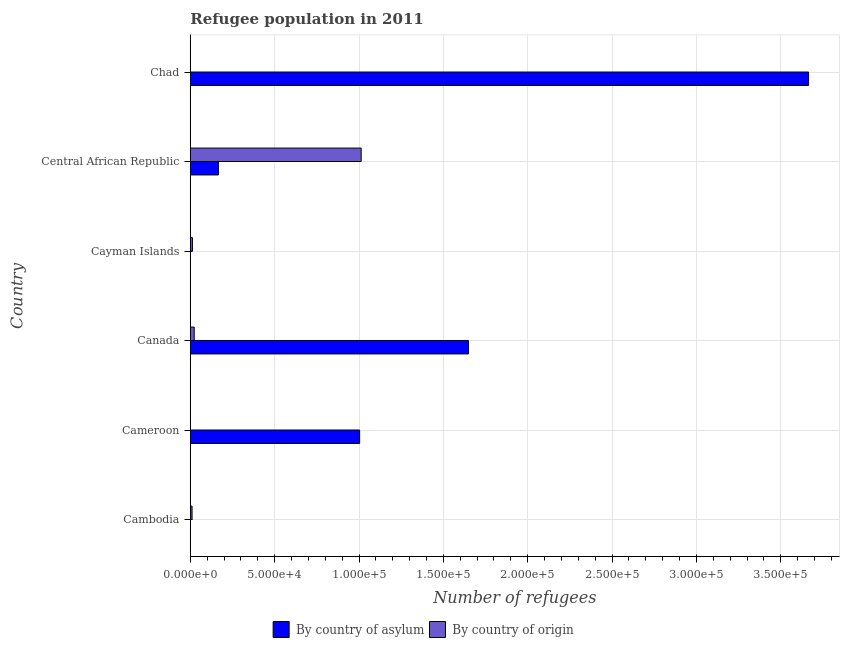How many different coloured bars are there?
Offer a terse response. 2. How many bars are there on the 1st tick from the top?
Keep it short and to the point. 2. What is the label of the 3rd group of bars from the top?
Offer a very short reply. Cayman Islands. What is the number of refugees by country of origin in Central African Republic?
Make the answer very short. 1.01e+05. Across all countries, what is the maximum number of refugees by country of asylum?
Offer a terse response. 3.66e+05. Across all countries, what is the minimum number of refugees by country of origin?
Provide a succinct answer. 1. In which country was the number of refugees by country of asylum maximum?
Ensure brevity in your answer.  Chad. In which country was the number of refugees by country of origin minimum?
Your answer should be very brief. Cameroon. What is the total number of refugees by country of asylum in the graph?
Your answer should be compact. 6.49e+05. What is the difference between the number of refugees by country of asylum in Canada and that in Cayman Islands?
Provide a succinct answer. 1.65e+05. What is the difference between the number of refugees by country of origin in Chad and the number of refugees by country of asylum in Cayman Islands?
Keep it short and to the point. 24. What is the average number of refugees by country of origin per country?
Keep it short and to the point. 1.77e+04. What is the difference between the number of refugees by country of origin and number of refugees by country of asylum in Chad?
Your answer should be compact. -3.66e+05. What is the ratio of the number of refugees by country of origin in Canada to that in Cayman Islands?
Give a very brief answer. 1.83. Is the number of refugees by country of asylum in Cambodia less than that in Cameroon?
Offer a terse response. Yes. Is the difference between the number of refugees by country of origin in Cambodia and Central African Republic greater than the difference between the number of refugees by country of asylum in Cambodia and Central African Republic?
Offer a very short reply. No. What is the difference between the highest and the second highest number of refugees by country of origin?
Give a very brief answer. 9.90e+04. What is the difference between the highest and the lowest number of refugees by country of asylum?
Ensure brevity in your answer.  3.66e+05. What does the 2nd bar from the top in Cambodia represents?
Make the answer very short. By country of asylum. What does the 1st bar from the bottom in Cambodia represents?
Your answer should be compact. By country of asylum. How many countries are there in the graph?
Offer a very short reply. 6. Does the graph contain any zero values?
Your answer should be very brief. No. Does the graph contain grids?
Keep it short and to the point. Yes. Where does the legend appear in the graph?
Keep it short and to the point. Bottom center. How are the legend labels stacked?
Offer a very short reply. Horizontal. What is the title of the graph?
Provide a short and direct response. Refugee population in 2011. What is the label or title of the X-axis?
Your response must be concise. Number of refugees. What is the Number of refugees in By country of asylum in Cambodia?
Your answer should be compact. 64. What is the Number of refugees of By country of origin in Cambodia?
Provide a succinct answer. 1045. What is the Number of refugees of By country of asylum in Cameroon?
Your answer should be very brief. 1.00e+05. What is the Number of refugees in By country of asylum in Canada?
Offer a very short reply. 1.65e+05. What is the Number of refugees of By country of origin in Canada?
Provide a short and direct response. 2327. What is the Number of refugees of By country of origin in Cayman Islands?
Offer a terse response. 1271. What is the Number of refugees in By country of asylum in Central African Republic?
Your response must be concise. 1.67e+04. What is the Number of refugees of By country of origin in Central African Republic?
Make the answer very short. 1.01e+05. What is the Number of refugees in By country of asylum in Chad?
Your answer should be compact. 3.66e+05. Across all countries, what is the maximum Number of refugees in By country of asylum?
Offer a very short reply. 3.66e+05. Across all countries, what is the maximum Number of refugees in By country of origin?
Your answer should be very brief. 1.01e+05. Across all countries, what is the minimum Number of refugees in By country of asylum?
Keep it short and to the point. 3. Across all countries, what is the minimum Number of refugees in By country of origin?
Your response must be concise. 1. What is the total Number of refugees of By country of asylum in the graph?
Your answer should be compact. 6.49e+05. What is the total Number of refugees of By country of origin in the graph?
Make the answer very short. 1.06e+05. What is the difference between the Number of refugees of By country of asylum in Cambodia and that in Cameroon?
Your answer should be very brief. -1.00e+05. What is the difference between the Number of refugees of By country of origin in Cambodia and that in Cameroon?
Provide a succinct answer. 1044. What is the difference between the Number of refugees of By country of asylum in Cambodia and that in Canada?
Your answer should be very brief. -1.65e+05. What is the difference between the Number of refugees of By country of origin in Cambodia and that in Canada?
Your answer should be compact. -1282. What is the difference between the Number of refugees of By country of asylum in Cambodia and that in Cayman Islands?
Provide a succinct answer. 61. What is the difference between the Number of refugees in By country of origin in Cambodia and that in Cayman Islands?
Make the answer very short. -226. What is the difference between the Number of refugees in By country of asylum in Cambodia and that in Central African Republic?
Your answer should be compact. -1.67e+04. What is the difference between the Number of refugees in By country of origin in Cambodia and that in Central African Republic?
Provide a succinct answer. -1.00e+05. What is the difference between the Number of refugees in By country of asylum in Cambodia and that in Chad?
Your response must be concise. -3.66e+05. What is the difference between the Number of refugees in By country of origin in Cambodia and that in Chad?
Keep it short and to the point. 1018. What is the difference between the Number of refugees of By country of asylum in Cameroon and that in Canada?
Provide a short and direct response. -6.45e+04. What is the difference between the Number of refugees in By country of origin in Cameroon and that in Canada?
Offer a very short reply. -2326. What is the difference between the Number of refugees in By country of asylum in Cameroon and that in Cayman Islands?
Ensure brevity in your answer.  1.00e+05. What is the difference between the Number of refugees in By country of origin in Cameroon and that in Cayman Islands?
Offer a very short reply. -1270. What is the difference between the Number of refugees in By country of asylum in Cameroon and that in Central African Republic?
Give a very brief answer. 8.36e+04. What is the difference between the Number of refugees of By country of origin in Cameroon and that in Central African Republic?
Offer a very short reply. -1.01e+05. What is the difference between the Number of refugees of By country of asylum in Cameroon and that in Chad?
Ensure brevity in your answer.  -2.66e+05. What is the difference between the Number of refugees of By country of asylum in Canada and that in Cayman Islands?
Ensure brevity in your answer.  1.65e+05. What is the difference between the Number of refugees in By country of origin in Canada and that in Cayman Islands?
Your answer should be very brief. 1056. What is the difference between the Number of refugees in By country of asylum in Canada and that in Central African Republic?
Give a very brief answer. 1.48e+05. What is the difference between the Number of refugees in By country of origin in Canada and that in Central African Republic?
Offer a very short reply. -9.90e+04. What is the difference between the Number of refugees of By country of asylum in Canada and that in Chad?
Offer a very short reply. -2.02e+05. What is the difference between the Number of refugees in By country of origin in Canada and that in Chad?
Ensure brevity in your answer.  2300. What is the difference between the Number of refugees in By country of asylum in Cayman Islands and that in Central African Republic?
Make the answer very short. -1.67e+04. What is the difference between the Number of refugees of By country of origin in Cayman Islands and that in Central African Republic?
Your answer should be very brief. -1.00e+05. What is the difference between the Number of refugees of By country of asylum in Cayman Islands and that in Chad?
Offer a terse response. -3.66e+05. What is the difference between the Number of refugees in By country of origin in Cayman Islands and that in Chad?
Your response must be concise. 1244. What is the difference between the Number of refugees in By country of asylum in Central African Republic and that in Chad?
Your answer should be compact. -3.50e+05. What is the difference between the Number of refugees in By country of origin in Central African Republic and that in Chad?
Offer a terse response. 1.01e+05. What is the difference between the Number of refugees of By country of asylum in Cambodia and the Number of refugees of By country of origin in Canada?
Your answer should be very brief. -2263. What is the difference between the Number of refugees in By country of asylum in Cambodia and the Number of refugees in By country of origin in Cayman Islands?
Give a very brief answer. -1207. What is the difference between the Number of refugees of By country of asylum in Cambodia and the Number of refugees of By country of origin in Central African Republic?
Your response must be concise. -1.01e+05. What is the difference between the Number of refugees of By country of asylum in Cambodia and the Number of refugees of By country of origin in Chad?
Keep it short and to the point. 37. What is the difference between the Number of refugees of By country of asylum in Cameroon and the Number of refugees of By country of origin in Canada?
Offer a terse response. 9.80e+04. What is the difference between the Number of refugees of By country of asylum in Cameroon and the Number of refugees of By country of origin in Cayman Islands?
Offer a very short reply. 9.91e+04. What is the difference between the Number of refugees in By country of asylum in Cameroon and the Number of refugees in By country of origin in Central African Republic?
Your answer should be very brief. -915. What is the difference between the Number of refugees in By country of asylum in Cameroon and the Number of refugees in By country of origin in Chad?
Provide a short and direct response. 1.00e+05. What is the difference between the Number of refugees in By country of asylum in Canada and the Number of refugees in By country of origin in Cayman Islands?
Offer a very short reply. 1.64e+05. What is the difference between the Number of refugees of By country of asylum in Canada and the Number of refugees of By country of origin in Central African Republic?
Your response must be concise. 6.36e+04. What is the difference between the Number of refugees of By country of asylum in Canada and the Number of refugees of By country of origin in Chad?
Your answer should be compact. 1.65e+05. What is the difference between the Number of refugees in By country of asylum in Cayman Islands and the Number of refugees in By country of origin in Central African Republic?
Your answer should be very brief. -1.01e+05. What is the difference between the Number of refugees of By country of asylum in Central African Republic and the Number of refugees of By country of origin in Chad?
Your answer should be compact. 1.67e+04. What is the average Number of refugees of By country of asylum per country?
Give a very brief answer. 1.08e+05. What is the average Number of refugees in By country of origin per country?
Ensure brevity in your answer.  1.77e+04. What is the difference between the Number of refugees of By country of asylum and Number of refugees of By country of origin in Cambodia?
Give a very brief answer. -981. What is the difference between the Number of refugees of By country of asylum and Number of refugees of By country of origin in Cameroon?
Ensure brevity in your answer.  1.00e+05. What is the difference between the Number of refugees in By country of asylum and Number of refugees in By country of origin in Canada?
Keep it short and to the point. 1.63e+05. What is the difference between the Number of refugees in By country of asylum and Number of refugees in By country of origin in Cayman Islands?
Offer a very short reply. -1268. What is the difference between the Number of refugees of By country of asylum and Number of refugees of By country of origin in Central African Republic?
Your response must be concise. -8.46e+04. What is the difference between the Number of refugees in By country of asylum and Number of refugees in By country of origin in Chad?
Your answer should be compact. 3.66e+05. What is the ratio of the Number of refugees in By country of asylum in Cambodia to that in Cameroon?
Provide a succinct answer. 0. What is the ratio of the Number of refugees of By country of origin in Cambodia to that in Cameroon?
Your answer should be very brief. 1045. What is the ratio of the Number of refugees of By country of origin in Cambodia to that in Canada?
Your answer should be very brief. 0.45. What is the ratio of the Number of refugees in By country of asylum in Cambodia to that in Cayman Islands?
Offer a very short reply. 21.33. What is the ratio of the Number of refugees in By country of origin in Cambodia to that in Cayman Islands?
Make the answer very short. 0.82. What is the ratio of the Number of refugees in By country of asylum in Cambodia to that in Central African Republic?
Give a very brief answer. 0. What is the ratio of the Number of refugees of By country of origin in Cambodia to that in Central African Republic?
Your answer should be very brief. 0.01. What is the ratio of the Number of refugees in By country of asylum in Cambodia to that in Chad?
Ensure brevity in your answer.  0. What is the ratio of the Number of refugees in By country of origin in Cambodia to that in Chad?
Offer a very short reply. 38.7. What is the ratio of the Number of refugees of By country of asylum in Cameroon to that in Canada?
Make the answer very short. 0.61. What is the ratio of the Number of refugees of By country of origin in Cameroon to that in Canada?
Ensure brevity in your answer.  0. What is the ratio of the Number of refugees of By country of asylum in Cameroon to that in Cayman Islands?
Give a very brief answer. 3.35e+04. What is the ratio of the Number of refugees in By country of origin in Cameroon to that in Cayman Islands?
Provide a succinct answer. 0. What is the ratio of the Number of refugees in By country of asylum in Cameroon to that in Central African Republic?
Offer a terse response. 6. What is the ratio of the Number of refugees in By country of asylum in Cameroon to that in Chad?
Give a very brief answer. 0.27. What is the ratio of the Number of refugees of By country of origin in Cameroon to that in Chad?
Your answer should be compact. 0.04. What is the ratio of the Number of refugees of By country of asylum in Canada to that in Cayman Islands?
Offer a terse response. 5.50e+04. What is the ratio of the Number of refugees of By country of origin in Canada to that in Cayman Islands?
Your answer should be very brief. 1.83. What is the ratio of the Number of refugees of By country of asylum in Canada to that in Central African Republic?
Provide a short and direct response. 9.86. What is the ratio of the Number of refugees of By country of origin in Canada to that in Central African Republic?
Ensure brevity in your answer.  0.02. What is the ratio of the Number of refugees of By country of asylum in Canada to that in Chad?
Provide a succinct answer. 0.45. What is the ratio of the Number of refugees in By country of origin in Canada to that in Chad?
Give a very brief answer. 86.19. What is the ratio of the Number of refugees of By country of origin in Cayman Islands to that in Central African Republic?
Your response must be concise. 0.01. What is the ratio of the Number of refugees of By country of origin in Cayman Islands to that in Chad?
Give a very brief answer. 47.07. What is the ratio of the Number of refugees of By country of asylum in Central African Republic to that in Chad?
Offer a very short reply. 0.05. What is the ratio of the Number of refugees in By country of origin in Central African Republic to that in Chad?
Keep it short and to the point. 3751.41. What is the difference between the highest and the second highest Number of refugees of By country of asylum?
Your response must be concise. 2.02e+05. What is the difference between the highest and the second highest Number of refugees of By country of origin?
Keep it short and to the point. 9.90e+04. What is the difference between the highest and the lowest Number of refugees in By country of asylum?
Your answer should be compact. 3.66e+05. What is the difference between the highest and the lowest Number of refugees in By country of origin?
Your answer should be very brief. 1.01e+05. 